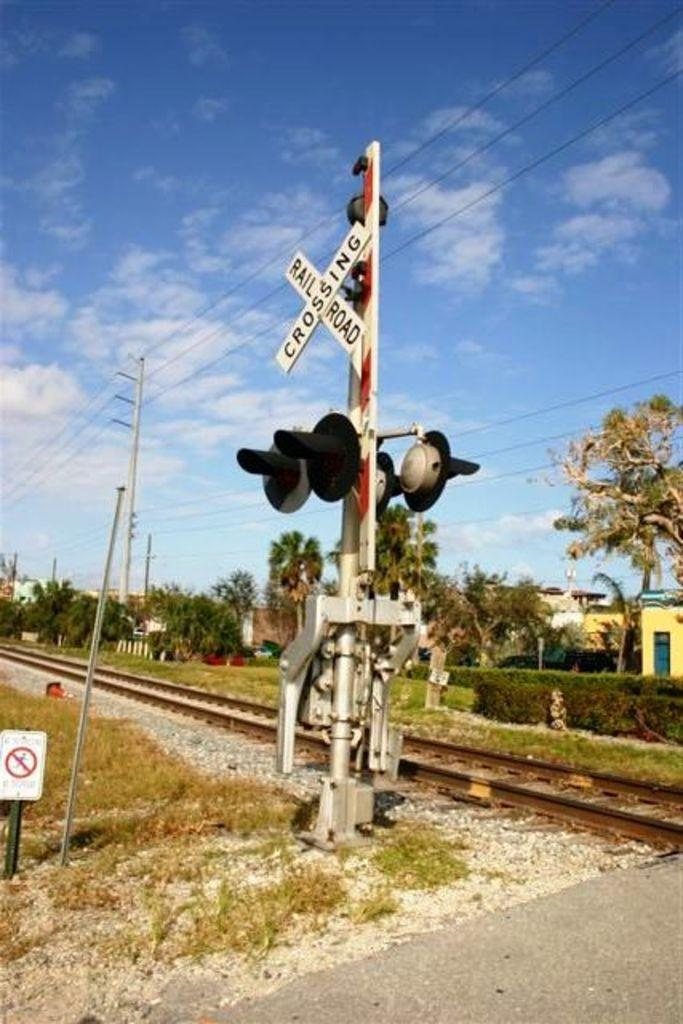<image>
Write a terse but informative summary of the picture. A railroad crossing sign is placed next to a rail road. 